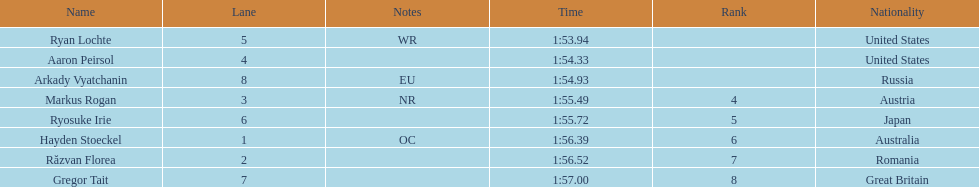What is the name of the contestant in lane 6? Ryosuke Irie. How long did it take that player to complete the race? 1:55.72. 